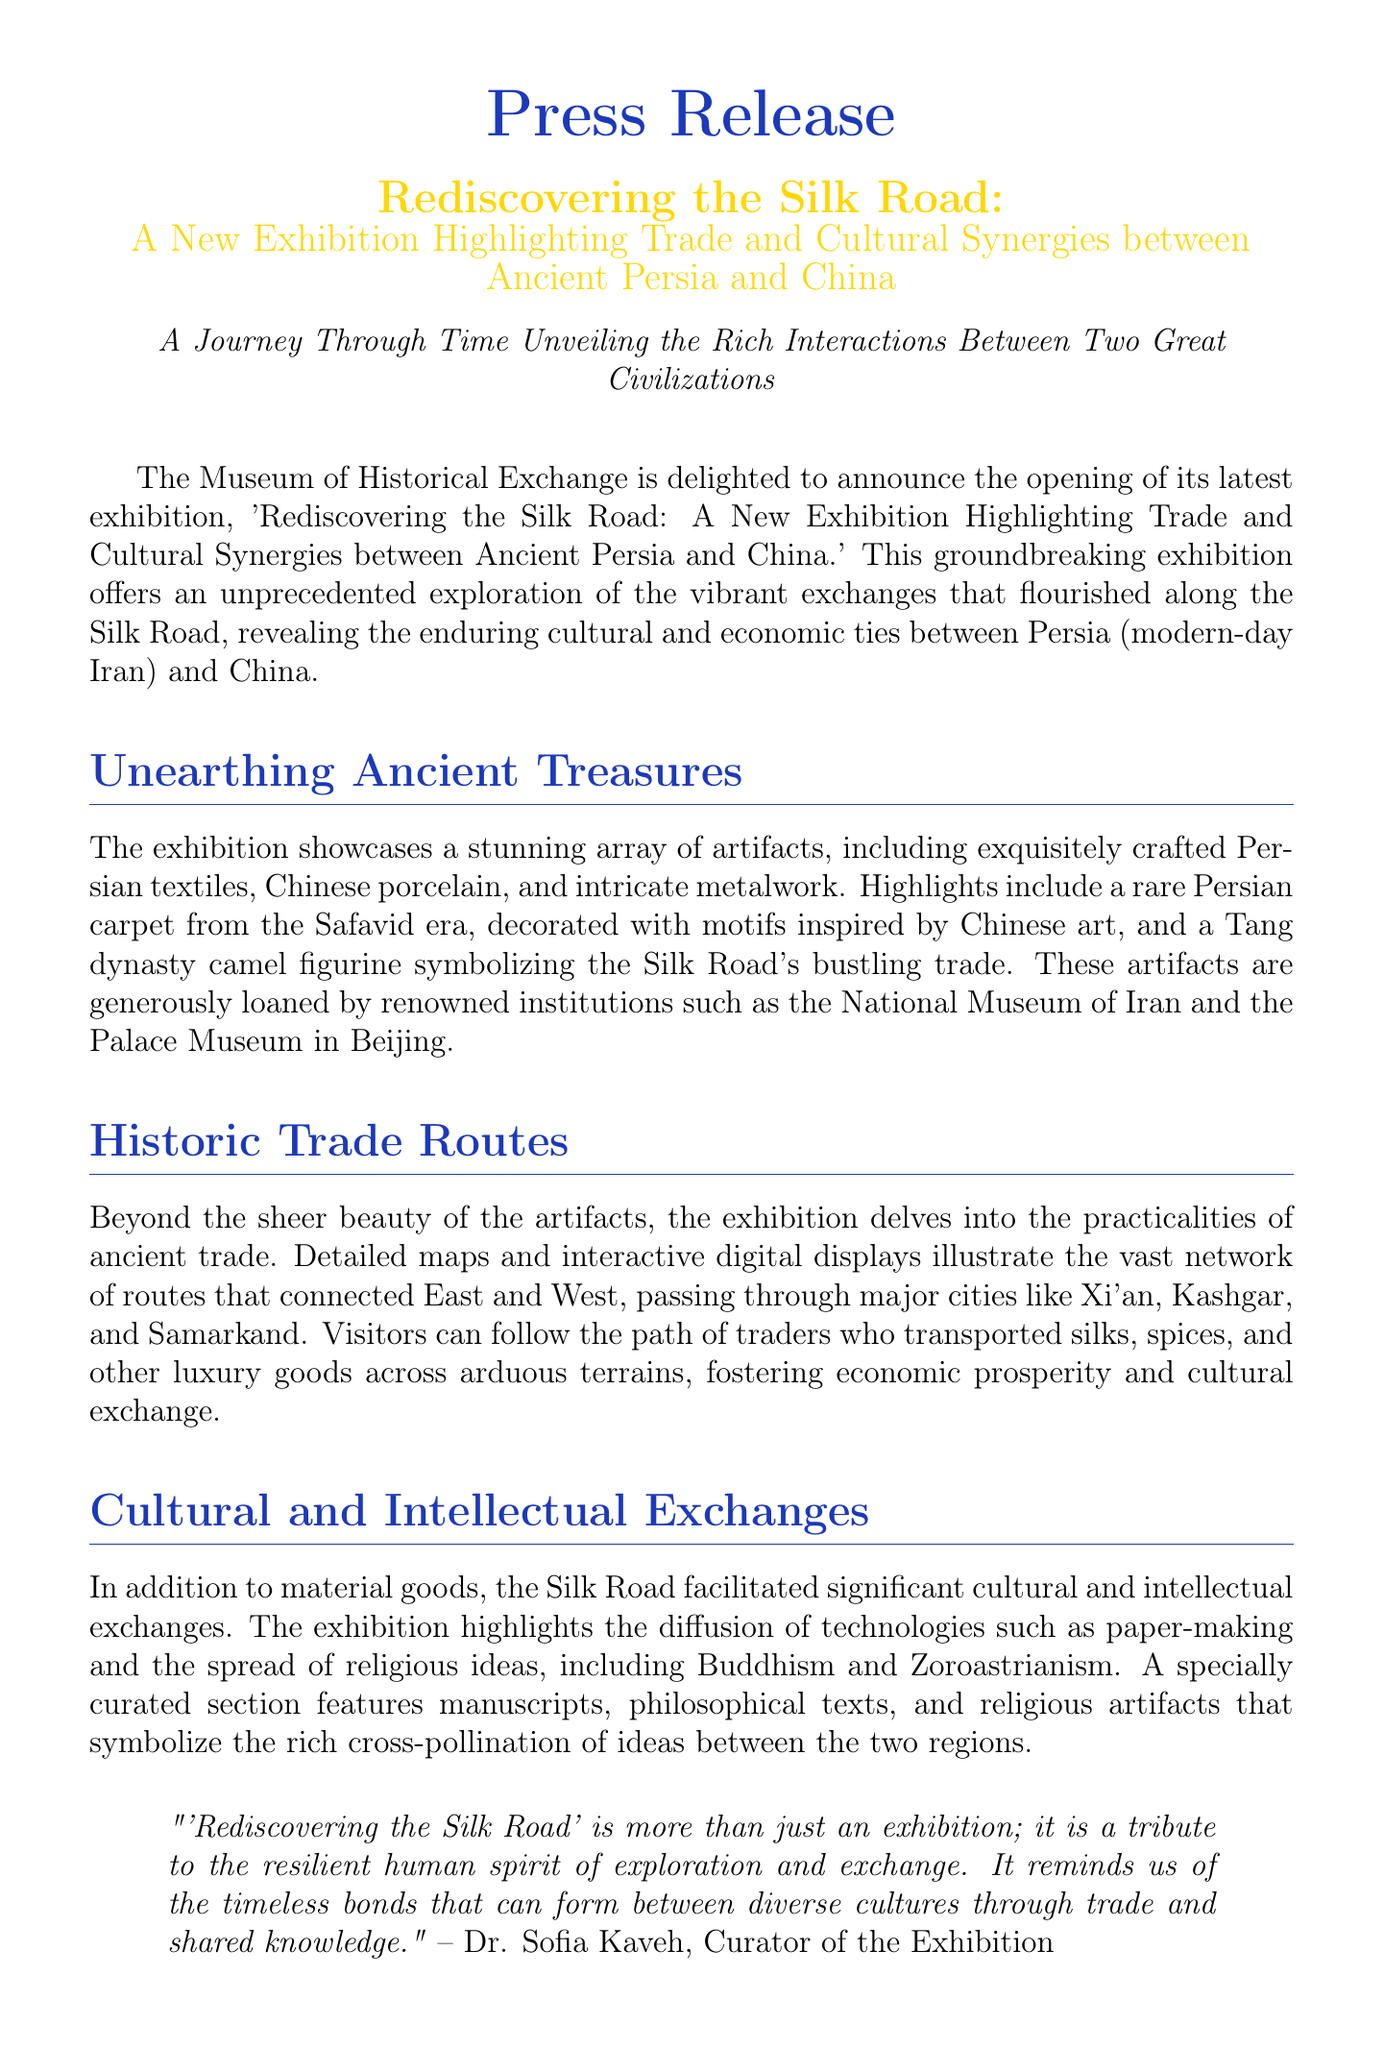What is the title of the exhibition? The title of the exhibition is mentioned prominently at the beginning of the document as "Rediscovering the Silk Road: A New Exhibition Highlighting Trade and Cultural Synergies between Ancient Persia and China."
Answer: Rediscovering the Silk Road Who is the curator of the exhibition? The curator of the exhibition is quoted in the document, providing their name and a statement.
Answer: Dr. Sofia Kaveh What artifact represents the Safavid era? The document specifically highlights a rare Persian carpet from the Safavid era as a significant artifact.
Answer: Persian carpet When does the exhibition open to the public? The opening date is specified in the document, marking the start of public access to the exhibition.
Answer: March 15, 2023 What significant cultural technology spread along the Silk Road? The exhibition highlights the diffusion of various technologies, specifically mentioning one in the context of cultural exchange.
Answer: Paper-making Which two religions are mentioned in the context of the Silk Road's exchanges? The document discusses the spread of specific religious ideas along the Silk Road, identifying two notable religions.
Answer: Buddhism and Zoroastrianism What are the admission fees for museum members? The document clearly states the admission policy for members of the Museum of Historical Exchange.
Answer: Free Name one of the institutions that loaned artifacts for the exhibition. The document lists renowned institutions that contributed artifacts, mentioning one specifically.
Answer: National Museum of Iran 